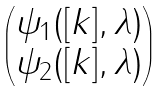<formula> <loc_0><loc_0><loc_500><loc_500>\begin{pmatrix} \psi _ { 1 } ( [ k ] , \lambda ) \\ \psi _ { 2 } ( [ k ] , \lambda ) \end{pmatrix}</formula> 